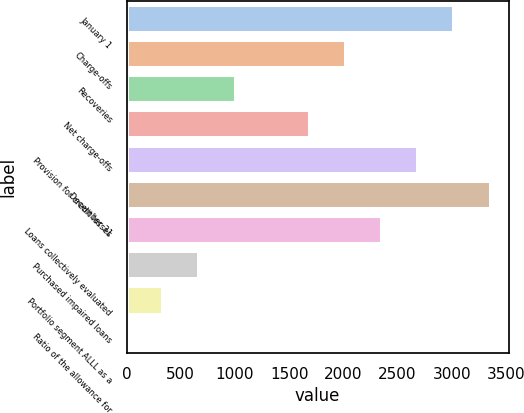<chart> <loc_0><loc_0><loc_500><loc_500><bar_chart><fcel>January 1<fcel>Charge-offs<fcel>Recoveries<fcel>Net charge-offs<fcel>Provision for credit losses<fcel>December 31<fcel>Loans collectively evaluated<fcel>Purchased impaired loans<fcel>Portfolio segment ALLL as a<fcel>Ratio of the allowance for<nl><fcel>3025.4<fcel>2023.1<fcel>1006.27<fcel>1689<fcel>2691.3<fcel>3359.5<fcel>2357.2<fcel>672.17<fcel>338.07<fcel>3.97<nl></chart> 